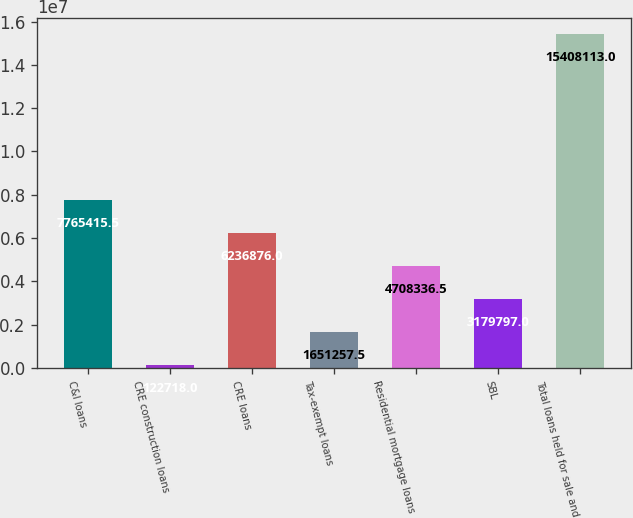<chart> <loc_0><loc_0><loc_500><loc_500><bar_chart><fcel>C&I loans<fcel>CRE construction loans<fcel>CRE loans<fcel>Tax-exempt loans<fcel>Residential mortgage loans<fcel>SBL<fcel>Total loans held for sale and<nl><fcel>7.76542e+06<fcel>122718<fcel>6.23688e+06<fcel>1.65126e+06<fcel>4.70834e+06<fcel>3.1798e+06<fcel>1.54081e+07<nl></chart> 